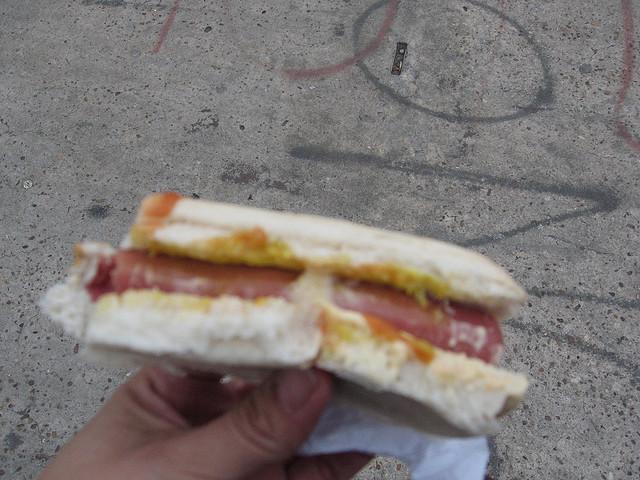How many cows are in the background?
Give a very brief answer. 0. 